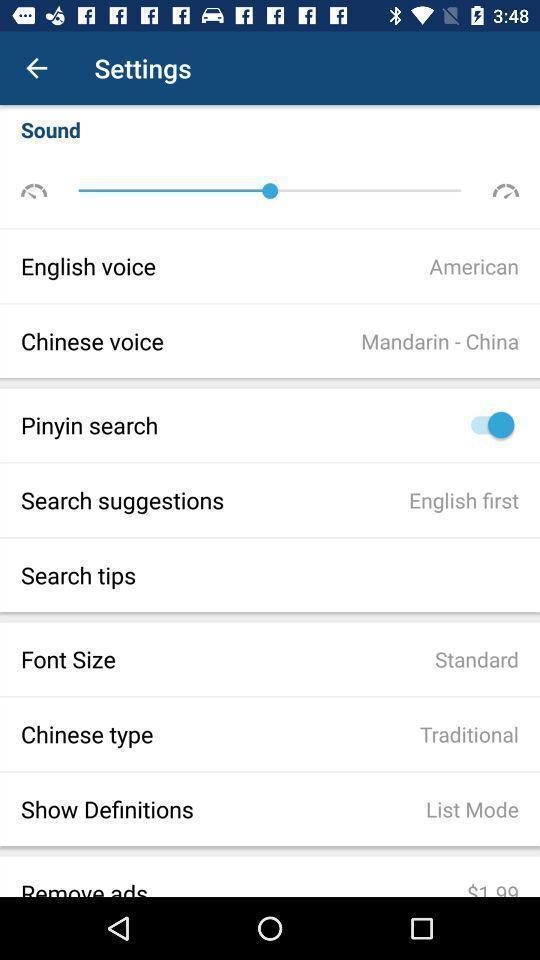Describe this image in words. Settings page. 